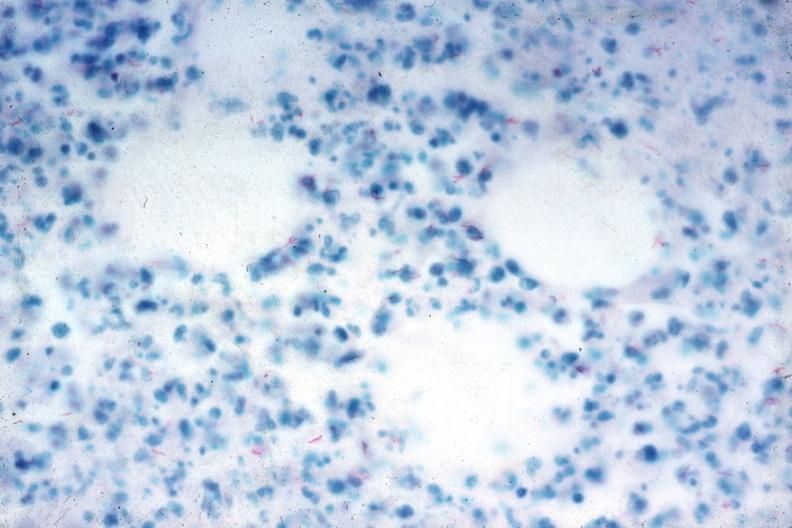what does this image show?
Answer the question using a single word or phrase. Acid fast stain numerous acid fast bacilli very good slide 